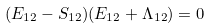Convert formula to latex. <formula><loc_0><loc_0><loc_500><loc_500>( E _ { 1 2 } - S _ { 1 2 } ) ( E _ { 1 2 } + \Lambda _ { 1 2 } ) = 0</formula> 